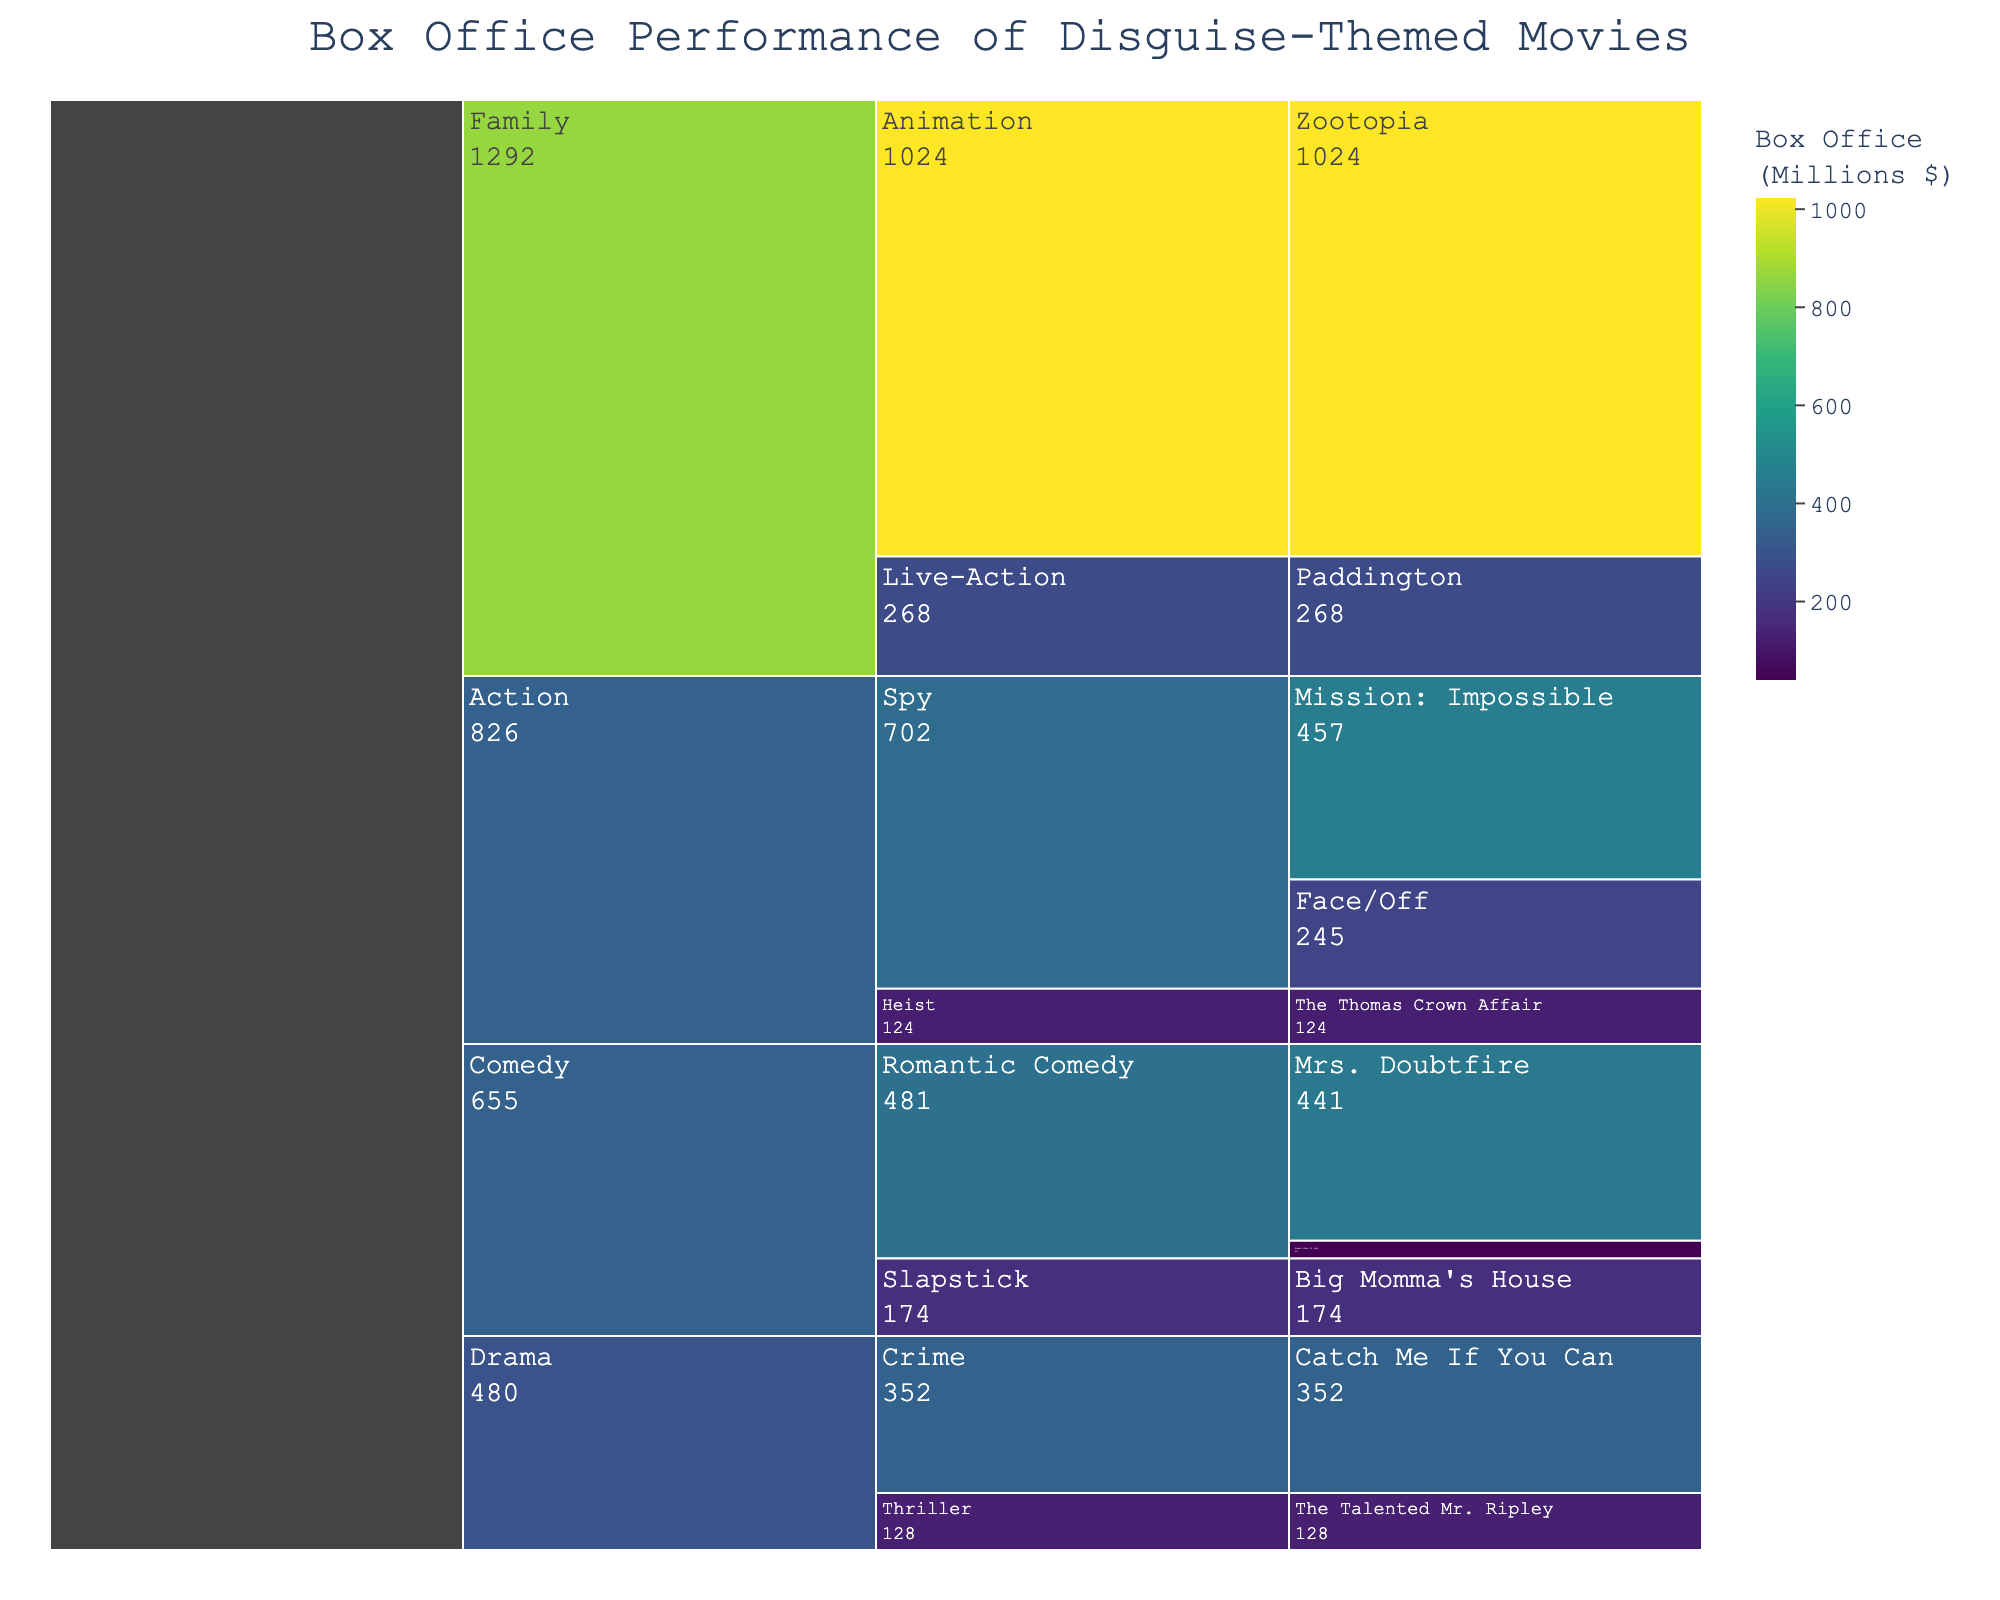What is the title of the figure? The title of the figure is displayed at the top of the chart.
Answer: Box Office Performance of Disguise-Themed Movies What genre has the highest box office performance? By looking at the hierarchical structure and the values in the figure, we can see which genre has the highest cumulative box office value.
Answer: Family What is the total box office performance of Comedy movies? Sum the box office values of all movies under the Comedy genre (Mrs. Doubtfire, Some Like It Hot, and Big Momma's House) from the figure. 441 + 40 + 174 = 655
Answer: 655 Which movie in the Action genre had the highest box office earnings? Compare the box office values of the movies under the Action genre in the figure.
Answer: Mission: Impossible How does the box office performance of Zootopia compare to the total box office of the Drama genre? Find the box office of Zootopia and sum the box office of all movies under the Drama genre. Zootopia: 1024, Drama: 352 + 128 = 480. Then compare.
Answer: Zootopia is higher Which sub-genre in the Family genre generated the most revenue? Compare the box office values of the sub-genres (Animation and Live-Action) under Family.
Answer: Animation What is the combined box office performance of the movies in the Spy sub-genre? Add the box office values of the Spy sub-genre's movies (Mission: Impossible and Face/Off). 457 + 245 = 702
Answer: 702 How many movies in total are listed under the Drama genre? Count the number of movies under the Drama genre in the figure.
Answer: 2 Which genre has the least number of movies listed? Compare the number of movies listed under each genre in the figure.
Answer: Action and Family (tie, each has 2 movies) What is the average box office performance of movies in the Heist sub-genre? Compute the average by summing the box office values of Heist movies and dividing by the number of movies. (124/1 = 124)
Answer: 124 